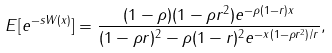<formula> <loc_0><loc_0><loc_500><loc_500>E [ e ^ { - s W ( x ) } ] = \frac { ( 1 - \rho ) ( 1 - \rho r ^ { 2 } ) e ^ { - \rho ( 1 - r ) x } } { ( 1 - \rho r ) ^ { 2 } - \rho ( 1 - r ) ^ { 2 } e ^ { - x ( 1 - \rho r ^ { 2 } ) / r } } ,</formula> 